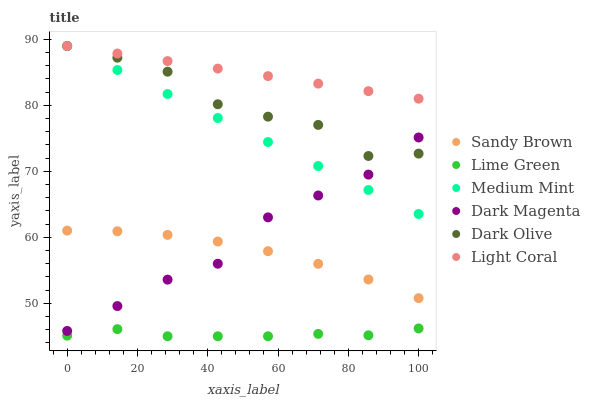Does Lime Green have the minimum area under the curve?
Answer yes or no. Yes. Does Light Coral have the maximum area under the curve?
Answer yes or no. Yes. Does Dark Magenta have the minimum area under the curve?
Answer yes or no. No. Does Dark Magenta have the maximum area under the curve?
Answer yes or no. No. Is Medium Mint the smoothest?
Answer yes or no. Yes. Is Dark Olive the roughest?
Answer yes or no. Yes. Is Dark Magenta the smoothest?
Answer yes or no. No. Is Dark Magenta the roughest?
Answer yes or no. No. Does Lime Green have the lowest value?
Answer yes or no. Yes. Does Dark Magenta have the lowest value?
Answer yes or no. No. Does Light Coral have the highest value?
Answer yes or no. Yes. Does Dark Magenta have the highest value?
Answer yes or no. No. Is Lime Green less than Dark Magenta?
Answer yes or no. Yes. Is Light Coral greater than Dark Magenta?
Answer yes or no. Yes. Does Medium Mint intersect Light Coral?
Answer yes or no. Yes. Is Medium Mint less than Light Coral?
Answer yes or no. No. Is Medium Mint greater than Light Coral?
Answer yes or no. No. Does Lime Green intersect Dark Magenta?
Answer yes or no. No. 